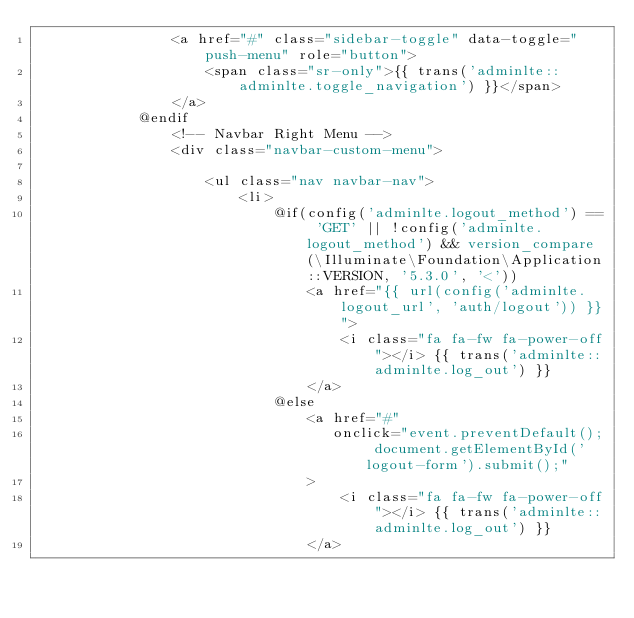Convert code to text. <code><loc_0><loc_0><loc_500><loc_500><_PHP_>                <a href="#" class="sidebar-toggle" data-toggle="push-menu" role="button">
                    <span class="sr-only">{{ trans('adminlte::adminlte.toggle_navigation') }}</span>
                </a>
            @endif
                <!-- Navbar Right Menu -->
                <div class="navbar-custom-menu">

                    <ul class="nav navbar-nav">
                        <li>
                            @if(config('adminlte.logout_method') == 'GET' || !config('adminlte.logout_method') && version_compare(\Illuminate\Foundation\Application::VERSION, '5.3.0', '<'))
                                <a href="{{ url(config('adminlte.logout_url', 'auth/logout')) }}">
                                    <i class="fa fa-fw fa-power-off"></i> {{ trans('adminlte::adminlte.log_out') }}
                                </a>
                            @else
                                <a href="#"
                                   onclick="event.preventDefault(); document.getElementById('logout-form').submit();"
                                >
                                    <i class="fa fa-fw fa-power-off"></i> {{ trans('adminlte::adminlte.log_out') }}
                                </a></code> 